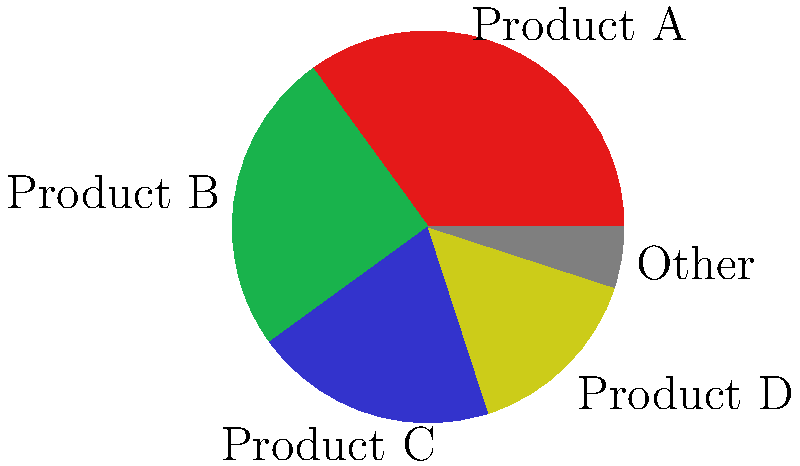Based on the pie chart representing the voting distribution for the 2015 ENnie Awards, which two categories combined account for 60% of the total votes? To solve this question, let's follow these steps:

1. Identify the percentages for each category:
   Product A: 35%
   Product B: 25%
   Product C: 20%
   Product D: 15%
   Other: 5%

2. We need to find two categories that sum up to 60%. Let's start with the largest percentage and work our way down:

3. Product A (35%) + Product B (25%) = 60%

4. This combination gives us exactly 60%, which is what we're looking for.

5. No other combination of two categories will give us exactly 60%:
   - Product A (35%) + Product C (20%) = 55%
   - Product A (35%) + Product D (15%) = 50%
   - Product B (25%) + Product C (20%) = 45%
   - etc.

Therefore, Product A and Product B are the two categories that combined account for 60% of the total votes.
Answer: Product A and Product B 